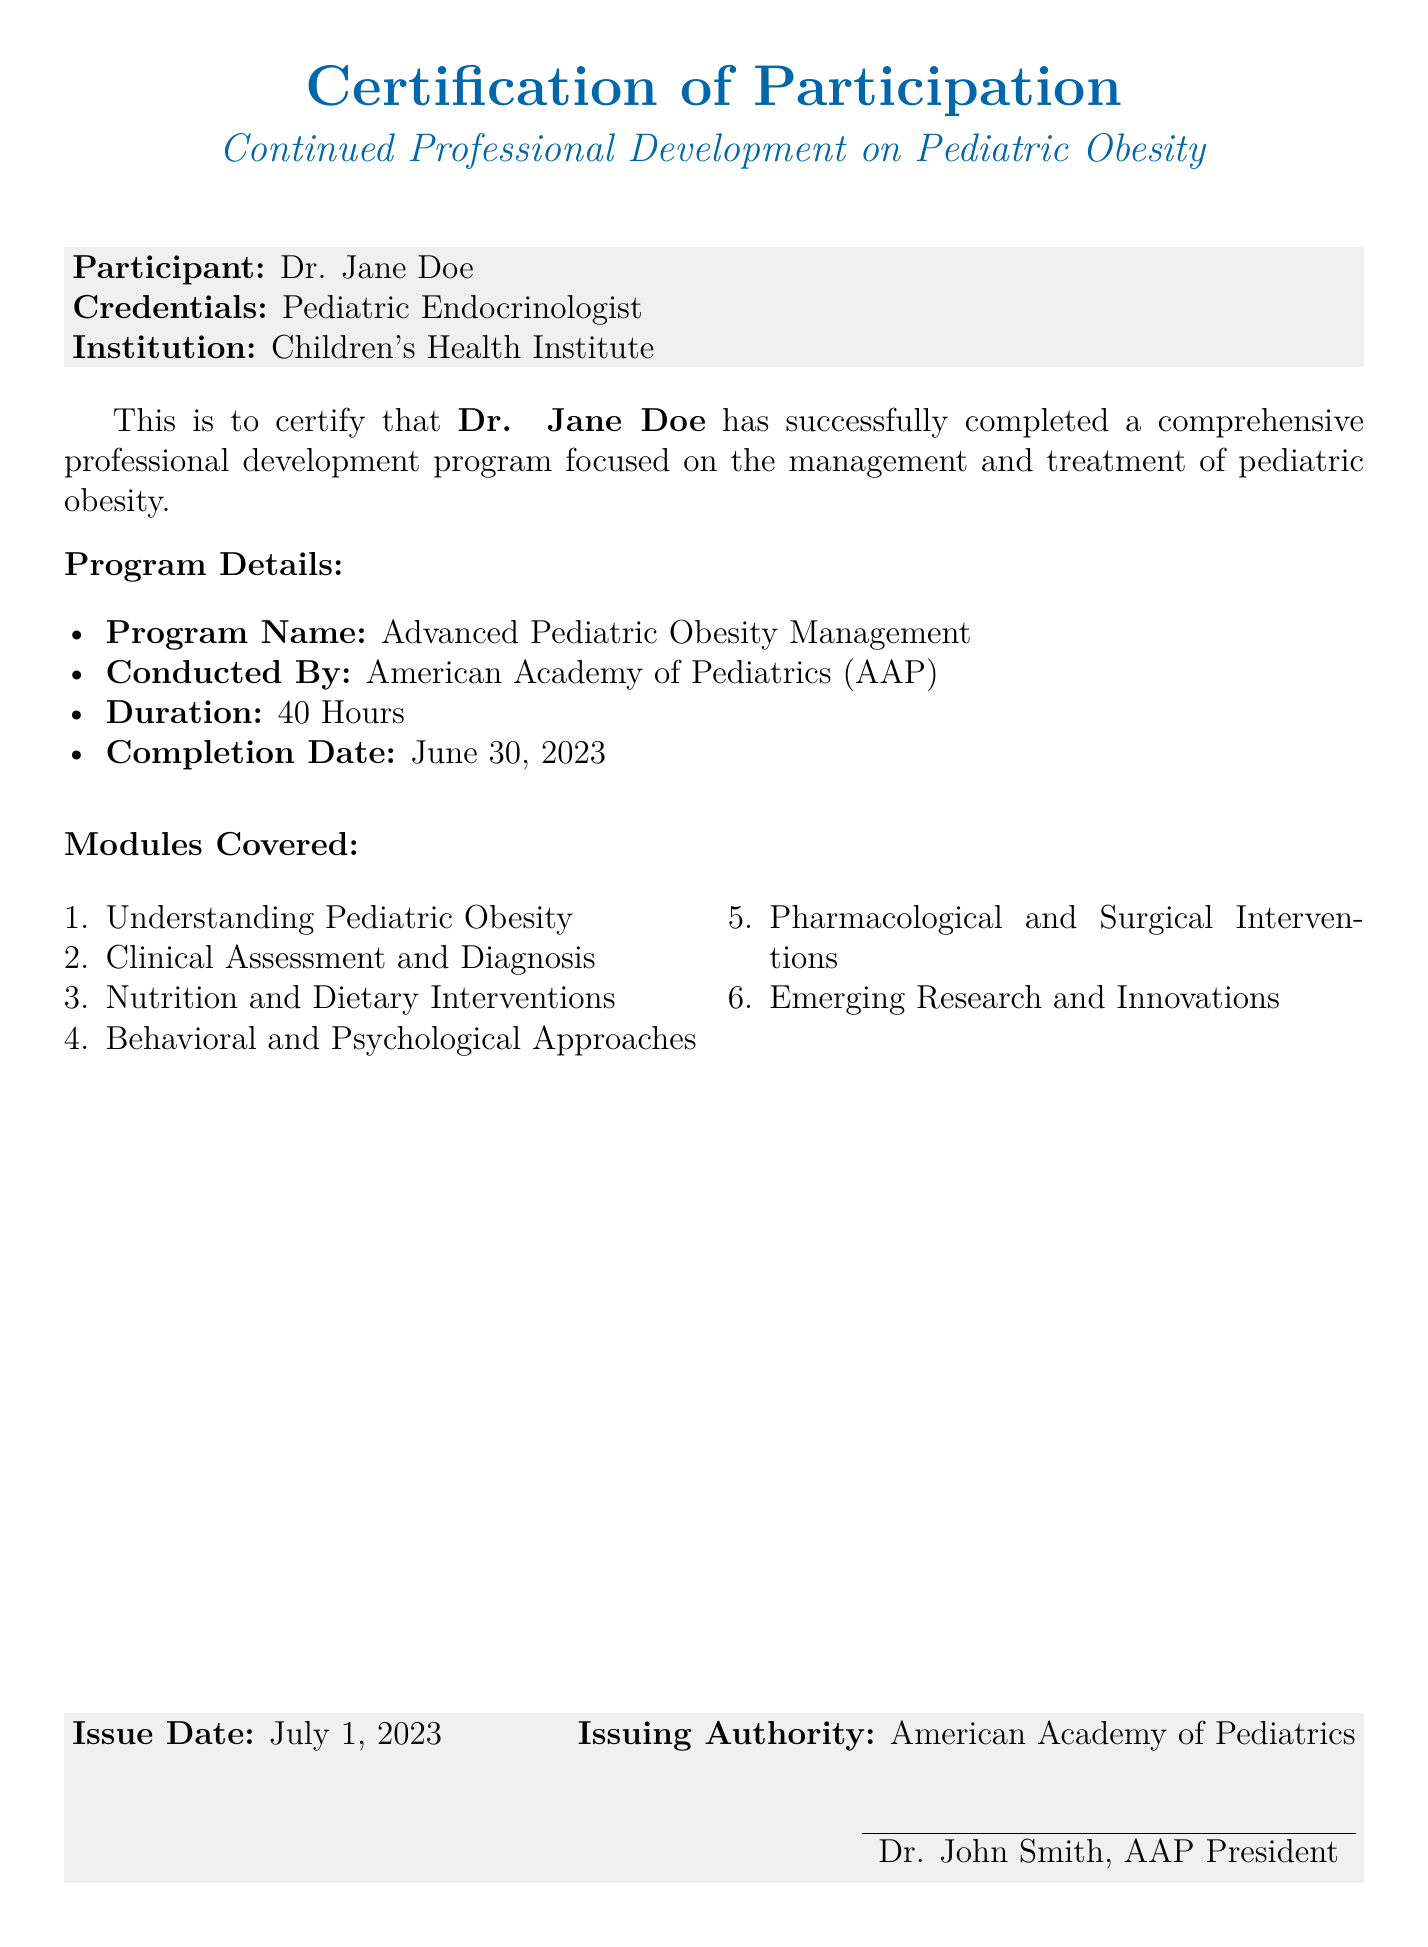what is the name of the participant? The name of the participant is provided in the document as Dr. Jane Doe.
Answer: Dr. Jane Doe what is the institution associated with the participant? The institution associated with the participant is mentioned in the document.
Answer: Children's Health Institute who conducted the program? The document specifies who conducted the professional development program.
Answer: American Academy of Pediatrics (AAP) how many hours was the program? The duration of the program is stated clearly in the document.
Answer: 40 Hours what was the completion date of the program? The completion date is explicitly listed in the document.
Answer: June 30, 2023 what are the modules covered in the program? The document lists several modules that were covered in the program.
Answer: Understanding Pediatric Obesity, Clinical Assessment and Diagnosis, Nutrition and Dietary Interventions, Behavioral and Psychological Approaches, Pharmacological and Surgical Interventions, Emerging Research and Innovations who signed the certification? The document contains the name of the person who signed the certification.
Answer: Dr. John Smith when was the certification issued? The issue date is provided clearly in the document.
Answer: July 1, 2023 what is the primary focus of the professional development program? The focus of the program is stated in the title of the certification.
Answer: Pediatric Obesity 